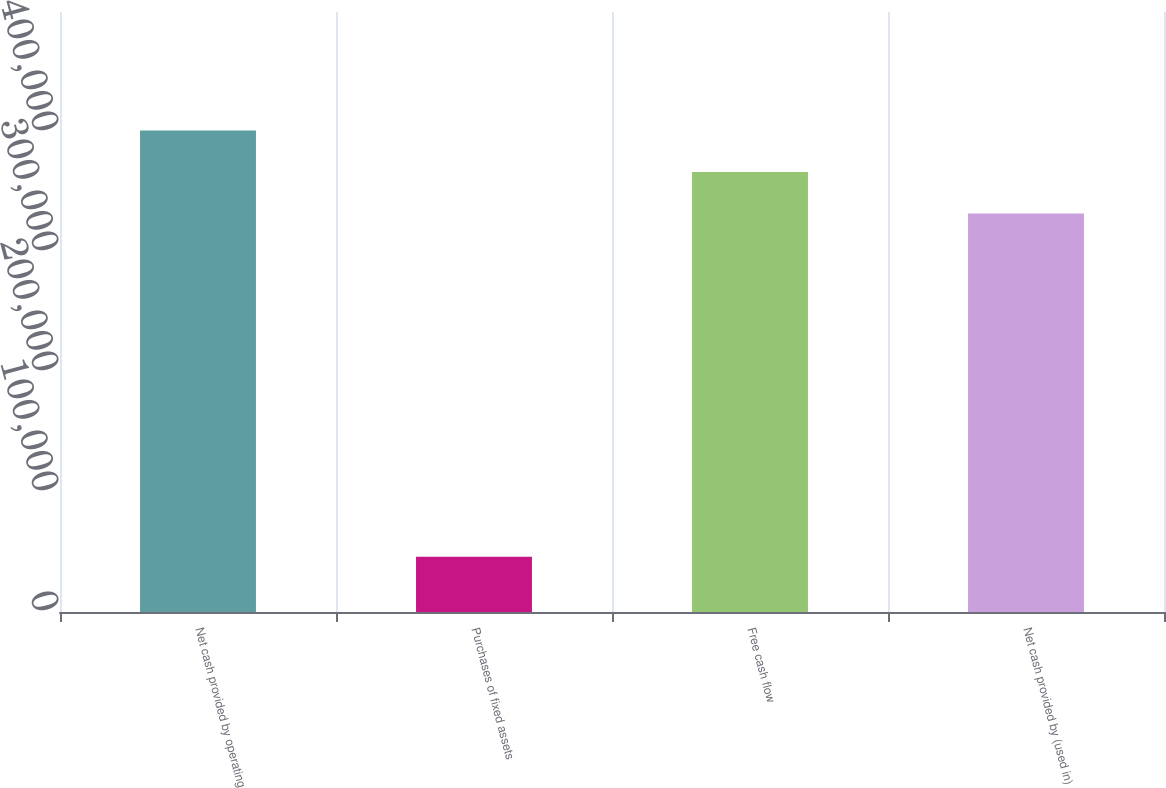Convert chart. <chart><loc_0><loc_0><loc_500><loc_500><bar_chart><fcel>Net cash provided by operating<fcel>Purchases of fixed assets<fcel>Free cash flow<fcel>Net cash provided by (used in)<nl><fcel>401198<fcel>45963<fcel>366592<fcel>331986<nl></chart> 